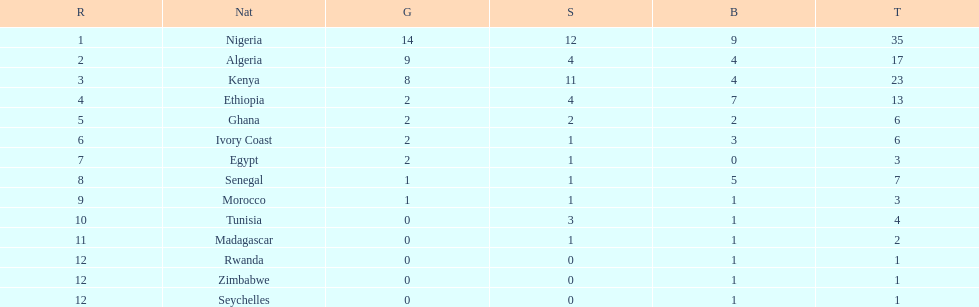How long is the list of countries that won any medals? 14. 